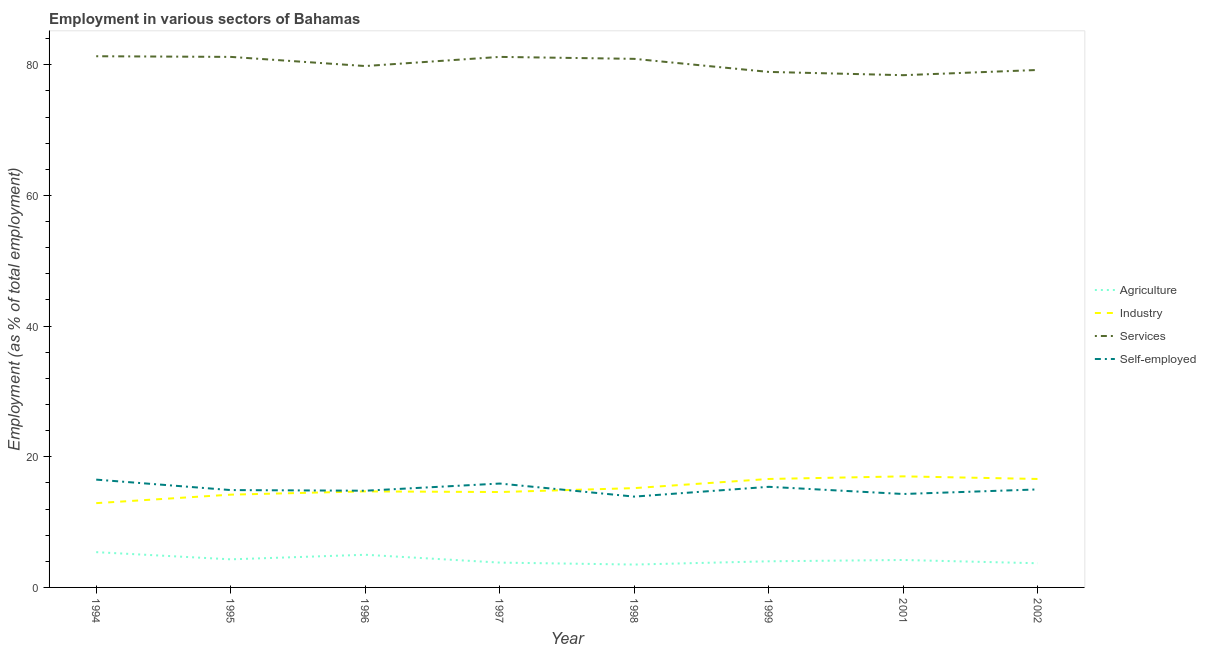How many different coloured lines are there?
Give a very brief answer. 4. What is the percentage of workers in agriculture in 1998?
Offer a very short reply. 3.5. Across all years, what is the maximum percentage of workers in services?
Your response must be concise. 81.3. In which year was the percentage of workers in industry maximum?
Offer a very short reply. 2001. What is the total percentage of workers in industry in the graph?
Your answer should be very brief. 121.8. What is the difference between the percentage of workers in industry in 1996 and that in 1998?
Keep it short and to the point. -0.5. What is the difference between the percentage of self employed workers in 2002 and the percentage of workers in agriculture in 2001?
Give a very brief answer. 10.8. What is the average percentage of workers in services per year?
Provide a short and direct response. 80.11. In the year 1995, what is the difference between the percentage of workers in industry and percentage of workers in services?
Give a very brief answer. -67. What is the ratio of the percentage of workers in services in 1995 to that in 1999?
Give a very brief answer. 1.03. Is the difference between the percentage of workers in agriculture in 1997 and 2001 greater than the difference between the percentage of workers in industry in 1997 and 2001?
Ensure brevity in your answer.  Yes. What is the difference between the highest and the second highest percentage of workers in agriculture?
Give a very brief answer. 0.4. What is the difference between the highest and the lowest percentage of self employed workers?
Your answer should be compact. 2.6. In how many years, is the percentage of workers in services greater than the average percentage of workers in services taken over all years?
Your answer should be compact. 4. Is the sum of the percentage of self employed workers in 1995 and 1997 greater than the maximum percentage of workers in agriculture across all years?
Keep it short and to the point. Yes. Does the percentage of workers in agriculture monotonically increase over the years?
Make the answer very short. No. How many lines are there?
Your answer should be very brief. 4. How many legend labels are there?
Your answer should be very brief. 4. What is the title of the graph?
Give a very brief answer. Employment in various sectors of Bahamas. What is the label or title of the Y-axis?
Your response must be concise. Employment (as % of total employment). What is the Employment (as % of total employment) in Agriculture in 1994?
Give a very brief answer. 5.4. What is the Employment (as % of total employment) of Industry in 1994?
Your answer should be very brief. 12.9. What is the Employment (as % of total employment) of Services in 1994?
Your answer should be compact. 81.3. What is the Employment (as % of total employment) of Agriculture in 1995?
Give a very brief answer. 4.3. What is the Employment (as % of total employment) in Industry in 1995?
Make the answer very short. 14.2. What is the Employment (as % of total employment) in Services in 1995?
Keep it short and to the point. 81.2. What is the Employment (as % of total employment) of Self-employed in 1995?
Provide a succinct answer. 14.9. What is the Employment (as % of total employment) of Agriculture in 1996?
Ensure brevity in your answer.  5. What is the Employment (as % of total employment) of Industry in 1996?
Your answer should be very brief. 14.7. What is the Employment (as % of total employment) in Services in 1996?
Ensure brevity in your answer.  79.8. What is the Employment (as % of total employment) in Self-employed in 1996?
Your answer should be very brief. 14.8. What is the Employment (as % of total employment) in Agriculture in 1997?
Ensure brevity in your answer.  3.8. What is the Employment (as % of total employment) of Industry in 1997?
Provide a short and direct response. 14.6. What is the Employment (as % of total employment) of Services in 1997?
Offer a terse response. 81.2. What is the Employment (as % of total employment) of Self-employed in 1997?
Provide a short and direct response. 15.9. What is the Employment (as % of total employment) in Agriculture in 1998?
Your answer should be compact. 3.5. What is the Employment (as % of total employment) of Industry in 1998?
Provide a succinct answer. 15.2. What is the Employment (as % of total employment) of Services in 1998?
Your answer should be compact. 80.9. What is the Employment (as % of total employment) of Self-employed in 1998?
Keep it short and to the point. 13.9. What is the Employment (as % of total employment) of Industry in 1999?
Make the answer very short. 16.6. What is the Employment (as % of total employment) of Services in 1999?
Offer a terse response. 78.9. What is the Employment (as % of total employment) in Self-employed in 1999?
Provide a short and direct response. 15.4. What is the Employment (as % of total employment) in Agriculture in 2001?
Offer a very short reply. 4.2. What is the Employment (as % of total employment) of Services in 2001?
Provide a succinct answer. 78.4. What is the Employment (as % of total employment) of Self-employed in 2001?
Make the answer very short. 14.3. What is the Employment (as % of total employment) in Agriculture in 2002?
Your response must be concise. 3.7. What is the Employment (as % of total employment) in Industry in 2002?
Ensure brevity in your answer.  16.6. What is the Employment (as % of total employment) in Services in 2002?
Your answer should be very brief. 79.2. What is the Employment (as % of total employment) of Self-employed in 2002?
Provide a succinct answer. 15. Across all years, what is the maximum Employment (as % of total employment) of Agriculture?
Offer a very short reply. 5.4. Across all years, what is the maximum Employment (as % of total employment) in Industry?
Make the answer very short. 17. Across all years, what is the maximum Employment (as % of total employment) of Services?
Provide a short and direct response. 81.3. Across all years, what is the maximum Employment (as % of total employment) of Self-employed?
Give a very brief answer. 16.5. Across all years, what is the minimum Employment (as % of total employment) of Industry?
Provide a short and direct response. 12.9. Across all years, what is the minimum Employment (as % of total employment) of Services?
Ensure brevity in your answer.  78.4. Across all years, what is the minimum Employment (as % of total employment) of Self-employed?
Keep it short and to the point. 13.9. What is the total Employment (as % of total employment) in Agriculture in the graph?
Ensure brevity in your answer.  33.9. What is the total Employment (as % of total employment) of Industry in the graph?
Keep it short and to the point. 121.8. What is the total Employment (as % of total employment) of Services in the graph?
Give a very brief answer. 640.9. What is the total Employment (as % of total employment) of Self-employed in the graph?
Make the answer very short. 120.7. What is the difference between the Employment (as % of total employment) of Self-employed in 1994 and that in 1995?
Provide a short and direct response. 1.6. What is the difference between the Employment (as % of total employment) in Agriculture in 1994 and that in 1996?
Ensure brevity in your answer.  0.4. What is the difference between the Employment (as % of total employment) of Services in 1994 and that in 1996?
Make the answer very short. 1.5. What is the difference between the Employment (as % of total employment) in Self-employed in 1994 and that in 1996?
Your response must be concise. 1.7. What is the difference between the Employment (as % of total employment) in Agriculture in 1994 and that in 1997?
Your response must be concise. 1.6. What is the difference between the Employment (as % of total employment) in Industry in 1994 and that in 1997?
Provide a succinct answer. -1.7. What is the difference between the Employment (as % of total employment) of Services in 1994 and that in 1997?
Give a very brief answer. 0.1. What is the difference between the Employment (as % of total employment) in Agriculture in 1994 and that in 1998?
Provide a succinct answer. 1.9. What is the difference between the Employment (as % of total employment) in Industry in 1994 and that in 1998?
Give a very brief answer. -2.3. What is the difference between the Employment (as % of total employment) of Services in 1994 and that in 1998?
Your answer should be compact. 0.4. What is the difference between the Employment (as % of total employment) in Self-employed in 1994 and that in 1998?
Your answer should be compact. 2.6. What is the difference between the Employment (as % of total employment) in Agriculture in 1994 and that in 1999?
Your answer should be very brief. 1.4. What is the difference between the Employment (as % of total employment) in Industry in 1994 and that in 1999?
Offer a very short reply. -3.7. What is the difference between the Employment (as % of total employment) of Services in 1994 and that in 1999?
Ensure brevity in your answer.  2.4. What is the difference between the Employment (as % of total employment) in Self-employed in 1994 and that in 1999?
Provide a short and direct response. 1.1. What is the difference between the Employment (as % of total employment) in Agriculture in 1994 and that in 2001?
Give a very brief answer. 1.2. What is the difference between the Employment (as % of total employment) in Industry in 1994 and that in 2001?
Provide a short and direct response. -4.1. What is the difference between the Employment (as % of total employment) of Services in 1994 and that in 2001?
Give a very brief answer. 2.9. What is the difference between the Employment (as % of total employment) of Self-employed in 1994 and that in 2001?
Provide a succinct answer. 2.2. What is the difference between the Employment (as % of total employment) of Agriculture in 1994 and that in 2002?
Keep it short and to the point. 1.7. What is the difference between the Employment (as % of total employment) in Services in 1994 and that in 2002?
Give a very brief answer. 2.1. What is the difference between the Employment (as % of total employment) in Agriculture in 1995 and that in 1996?
Your answer should be very brief. -0.7. What is the difference between the Employment (as % of total employment) of Services in 1995 and that in 1996?
Provide a succinct answer. 1.4. What is the difference between the Employment (as % of total employment) in Self-employed in 1995 and that in 1996?
Keep it short and to the point. 0.1. What is the difference between the Employment (as % of total employment) in Self-employed in 1995 and that in 1997?
Provide a short and direct response. -1. What is the difference between the Employment (as % of total employment) of Agriculture in 1995 and that in 1998?
Provide a succinct answer. 0.8. What is the difference between the Employment (as % of total employment) in Services in 1995 and that in 1998?
Your answer should be compact. 0.3. What is the difference between the Employment (as % of total employment) in Agriculture in 1995 and that in 1999?
Make the answer very short. 0.3. What is the difference between the Employment (as % of total employment) of Industry in 1995 and that in 1999?
Your response must be concise. -2.4. What is the difference between the Employment (as % of total employment) of Industry in 1995 and that in 2001?
Ensure brevity in your answer.  -2.8. What is the difference between the Employment (as % of total employment) in Services in 1995 and that in 2001?
Offer a terse response. 2.8. What is the difference between the Employment (as % of total employment) in Self-employed in 1995 and that in 2001?
Make the answer very short. 0.6. What is the difference between the Employment (as % of total employment) of Agriculture in 1995 and that in 2002?
Ensure brevity in your answer.  0.6. What is the difference between the Employment (as % of total employment) in Industry in 1995 and that in 2002?
Give a very brief answer. -2.4. What is the difference between the Employment (as % of total employment) of Agriculture in 1996 and that in 1997?
Your answer should be compact. 1.2. What is the difference between the Employment (as % of total employment) of Industry in 1996 and that in 1997?
Provide a succinct answer. 0.1. What is the difference between the Employment (as % of total employment) of Services in 1996 and that in 1997?
Your response must be concise. -1.4. What is the difference between the Employment (as % of total employment) of Self-employed in 1996 and that in 1997?
Offer a terse response. -1.1. What is the difference between the Employment (as % of total employment) of Industry in 1996 and that in 1998?
Make the answer very short. -0.5. What is the difference between the Employment (as % of total employment) in Self-employed in 1996 and that in 1998?
Provide a succinct answer. 0.9. What is the difference between the Employment (as % of total employment) in Self-employed in 1996 and that in 1999?
Keep it short and to the point. -0.6. What is the difference between the Employment (as % of total employment) in Agriculture in 1996 and that in 2001?
Your answer should be compact. 0.8. What is the difference between the Employment (as % of total employment) in Industry in 1996 and that in 2001?
Give a very brief answer. -2.3. What is the difference between the Employment (as % of total employment) in Services in 1996 and that in 2001?
Keep it short and to the point. 1.4. What is the difference between the Employment (as % of total employment) of Agriculture in 1996 and that in 2002?
Offer a very short reply. 1.3. What is the difference between the Employment (as % of total employment) in Services in 1996 and that in 2002?
Ensure brevity in your answer.  0.6. What is the difference between the Employment (as % of total employment) of Agriculture in 1997 and that in 1998?
Offer a terse response. 0.3. What is the difference between the Employment (as % of total employment) of Industry in 1997 and that in 1998?
Make the answer very short. -0.6. What is the difference between the Employment (as % of total employment) in Services in 1997 and that in 1998?
Offer a very short reply. 0.3. What is the difference between the Employment (as % of total employment) in Self-employed in 1997 and that in 1998?
Your response must be concise. 2. What is the difference between the Employment (as % of total employment) of Industry in 1997 and that in 1999?
Offer a terse response. -2. What is the difference between the Employment (as % of total employment) in Agriculture in 1997 and that in 2001?
Provide a succinct answer. -0.4. What is the difference between the Employment (as % of total employment) in Industry in 1997 and that in 2001?
Your answer should be very brief. -2.4. What is the difference between the Employment (as % of total employment) in Self-employed in 1997 and that in 2001?
Keep it short and to the point. 1.6. What is the difference between the Employment (as % of total employment) in Agriculture in 1997 and that in 2002?
Ensure brevity in your answer.  0.1. What is the difference between the Employment (as % of total employment) in Self-employed in 1997 and that in 2002?
Your answer should be very brief. 0.9. What is the difference between the Employment (as % of total employment) of Agriculture in 1998 and that in 1999?
Provide a short and direct response. -0.5. What is the difference between the Employment (as % of total employment) in Industry in 1998 and that in 1999?
Your answer should be compact. -1.4. What is the difference between the Employment (as % of total employment) of Services in 1998 and that in 1999?
Offer a terse response. 2. What is the difference between the Employment (as % of total employment) of Agriculture in 1998 and that in 2001?
Make the answer very short. -0.7. What is the difference between the Employment (as % of total employment) in Industry in 1998 and that in 2001?
Ensure brevity in your answer.  -1.8. What is the difference between the Employment (as % of total employment) of Services in 1998 and that in 2001?
Keep it short and to the point. 2.5. What is the difference between the Employment (as % of total employment) of Self-employed in 1998 and that in 2002?
Your response must be concise. -1.1. What is the difference between the Employment (as % of total employment) in Agriculture in 1999 and that in 2001?
Keep it short and to the point. -0.2. What is the difference between the Employment (as % of total employment) of Services in 1999 and that in 2001?
Provide a succinct answer. 0.5. What is the difference between the Employment (as % of total employment) of Self-employed in 1999 and that in 2001?
Offer a very short reply. 1.1. What is the difference between the Employment (as % of total employment) of Agriculture in 1999 and that in 2002?
Your response must be concise. 0.3. What is the difference between the Employment (as % of total employment) of Self-employed in 1999 and that in 2002?
Your answer should be very brief. 0.4. What is the difference between the Employment (as % of total employment) in Industry in 2001 and that in 2002?
Offer a very short reply. 0.4. What is the difference between the Employment (as % of total employment) of Self-employed in 2001 and that in 2002?
Provide a succinct answer. -0.7. What is the difference between the Employment (as % of total employment) in Agriculture in 1994 and the Employment (as % of total employment) in Industry in 1995?
Offer a very short reply. -8.8. What is the difference between the Employment (as % of total employment) of Agriculture in 1994 and the Employment (as % of total employment) of Services in 1995?
Make the answer very short. -75.8. What is the difference between the Employment (as % of total employment) of Industry in 1994 and the Employment (as % of total employment) of Services in 1995?
Provide a succinct answer. -68.3. What is the difference between the Employment (as % of total employment) in Services in 1994 and the Employment (as % of total employment) in Self-employed in 1995?
Make the answer very short. 66.4. What is the difference between the Employment (as % of total employment) of Agriculture in 1994 and the Employment (as % of total employment) of Services in 1996?
Offer a terse response. -74.4. What is the difference between the Employment (as % of total employment) in Agriculture in 1994 and the Employment (as % of total employment) in Self-employed in 1996?
Make the answer very short. -9.4. What is the difference between the Employment (as % of total employment) of Industry in 1994 and the Employment (as % of total employment) of Services in 1996?
Your answer should be very brief. -66.9. What is the difference between the Employment (as % of total employment) of Services in 1994 and the Employment (as % of total employment) of Self-employed in 1996?
Provide a succinct answer. 66.5. What is the difference between the Employment (as % of total employment) of Agriculture in 1994 and the Employment (as % of total employment) of Services in 1997?
Give a very brief answer. -75.8. What is the difference between the Employment (as % of total employment) of Industry in 1994 and the Employment (as % of total employment) of Services in 1997?
Keep it short and to the point. -68.3. What is the difference between the Employment (as % of total employment) in Industry in 1994 and the Employment (as % of total employment) in Self-employed in 1997?
Your answer should be very brief. -3. What is the difference between the Employment (as % of total employment) in Services in 1994 and the Employment (as % of total employment) in Self-employed in 1997?
Provide a short and direct response. 65.4. What is the difference between the Employment (as % of total employment) in Agriculture in 1994 and the Employment (as % of total employment) in Industry in 1998?
Your response must be concise. -9.8. What is the difference between the Employment (as % of total employment) of Agriculture in 1994 and the Employment (as % of total employment) of Services in 1998?
Offer a very short reply. -75.5. What is the difference between the Employment (as % of total employment) in Agriculture in 1994 and the Employment (as % of total employment) in Self-employed in 1998?
Provide a succinct answer. -8.5. What is the difference between the Employment (as % of total employment) of Industry in 1994 and the Employment (as % of total employment) of Services in 1998?
Keep it short and to the point. -68. What is the difference between the Employment (as % of total employment) of Industry in 1994 and the Employment (as % of total employment) of Self-employed in 1998?
Provide a succinct answer. -1. What is the difference between the Employment (as % of total employment) of Services in 1994 and the Employment (as % of total employment) of Self-employed in 1998?
Offer a terse response. 67.4. What is the difference between the Employment (as % of total employment) in Agriculture in 1994 and the Employment (as % of total employment) in Industry in 1999?
Keep it short and to the point. -11.2. What is the difference between the Employment (as % of total employment) in Agriculture in 1994 and the Employment (as % of total employment) in Services in 1999?
Offer a very short reply. -73.5. What is the difference between the Employment (as % of total employment) of Agriculture in 1994 and the Employment (as % of total employment) of Self-employed in 1999?
Keep it short and to the point. -10. What is the difference between the Employment (as % of total employment) in Industry in 1994 and the Employment (as % of total employment) in Services in 1999?
Your answer should be very brief. -66. What is the difference between the Employment (as % of total employment) in Industry in 1994 and the Employment (as % of total employment) in Self-employed in 1999?
Keep it short and to the point. -2.5. What is the difference between the Employment (as % of total employment) in Services in 1994 and the Employment (as % of total employment) in Self-employed in 1999?
Your response must be concise. 65.9. What is the difference between the Employment (as % of total employment) in Agriculture in 1994 and the Employment (as % of total employment) in Industry in 2001?
Provide a succinct answer. -11.6. What is the difference between the Employment (as % of total employment) in Agriculture in 1994 and the Employment (as % of total employment) in Services in 2001?
Your answer should be compact. -73. What is the difference between the Employment (as % of total employment) in Agriculture in 1994 and the Employment (as % of total employment) in Self-employed in 2001?
Give a very brief answer. -8.9. What is the difference between the Employment (as % of total employment) in Industry in 1994 and the Employment (as % of total employment) in Services in 2001?
Your answer should be very brief. -65.5. What is the difference between the Employment (as % of total employment) of Industry in 1994 and the Employment (as % of total employment) of Self-employed in 2001?
Your response must be concise. -1.4. What is the difference between the Employment (as % of total employment) in Services in 1994 and the Employment (as % of total employment) in Self-employed in 2001?
Your answer should be compact. 67. What is the difference between the Employment (as % of total employment) in Agriculture in 1994 and the Employment (as % of total employment) in Industry in 2002?
Your answer should be compact. -11.2. What is the difference between the Employment (as % of total employment) in Agriculture in 1994 and the Employment (as % of total employment) in Services in 2002?
Your answer should be compact. -73.8. What is the difference between the Employment (as % of total employment) of Industry in 1994 and the Employment (as % of total employment) of Services in 2002?
Offer a very short reply. -66.3. What is the difference between the Employment (as % of total employment) of Industry in 1994 and the Employment (as % of total employment) of Self-employed in 2002?
Your answer should be very brief. -2.1. What is the difference between the Employment (as % of total employment) in Services in 1994 and the Employment (as % of total employment) in Self-employed in 2002?
Make the answer very short. 66.3. What is the difference between the Employment (as % of total employment) of Agriculture in 1995 and the Employment (as % of total employment) of Industry in 1996?
Offer a terse response. -10.4. What is the difference between the Employment (as % of total employment) in Agriculture in 1995 and the Employment (as % of total employment) in Services in 1996?
Ensure brevity in your answer.  -75.5. What is the difference between the Employment (as % of total employment) in Industry in 1995 and the Employment (as % of total employment) in Services in 1996?
Give a very brief answer. -65.6. What is the difference between the Employment (as % of total employment) in Industry in 1995 and the Employment (as % of total employment) in Self-employed in 1996?
Your answer should be very brief. -0.6. What is the difference between the Employment (as % of total employment) of Services in 1995 and the Employment (as % of total employment) of Self-employed in 1996?
Ensure brevity in your answer.  66.4. What is the difference between the Employment (as % of total employment) of Agriculture in 1995 and the Employment (as % of total employment) of Industry in 1997?
Your answer should be very brief. -10.3. What is the difference between the Employment (as % of total employment) of Agriculture in 1995 and the Employment (as % of total employment) of Services in 1997?
Keep it short and to the point. -76.9. What is the difference between the Employment (as % of total employment) in Industry in 1995 and the Employment (as % of total employment) in Services in 1997?
Give a very brief answer. -67. What is the difference between the Employment (as % of total employment) of Services in 1995 and the Employment (as % of total employment) of Self-employed in 1997?
Your response must be concise. 65.3. What is the difference between the Employment (as % of total employment) of Agriculture in 1995 and the Employment (as % of total employment) of Industry in 1998?
Your answer should be compact. -10.9. What is the difference between the Employment (as % of total employment) in Agriculture in 1995 and the Employment (as % of total employment) in Services in 1998?
Your response must be concise. -76.6. What is the difference between the Employment (as % of total employment) in Agriculture in 1995 and the Employment (as % of total employment) in Self-employed in 1998?
Make the answer very short. -9.6. What is the difference between the Employment (as % of total employment) of Industry in 1995 and the Employment (as % of total employment) of Services in 1998?
Your answer should be very brief. -66.7. What is the difference between the Employment (as % of total employment) in Industry in 1995 and the Employment (as % of total employment) in Self-employed in 1998?
Keep it short and to the point. 0.3. What is the difference between the Employment (as % of total employment) in Services in 1995 and the Employment (as % of total employment) in Self-employed in 1998?
Offer a terse response. 67.3. What is the difference between the Employment (as % of total employment) in Agriculture in 1995 and the Employment (as % of total employment) in Services in 1999?
Ensure brevity in your answer.  -74.6. What is the difference between the Employment (as % of total employment) of Agriculture in 1995 and the Employment (as % of total employment) of Self-employed in 1999?
Keep it short and to the point. -11.1. What is the difference between the Employment (as % of total employment) of Industry in 1995 and the Employment (as % of total employment) of Services in 1999?
Your answer should be very brief. -64.7. What is the difference between the Employment (as % of total employment) in Industry in 1995 and the Employment (as % of total employment) in Self-employed in 1999?
Offer a terse response. -1.2. What is the difference between the Employment (as % of total employment) of Services in 1995 and the Employment (as % of total employment) of Self-employed in 1999?
Keep it short and to the point. 65.8. What is the difference between the Employment (as % of total employment) in Agriculture in 1995 and the Employment (as % of total employment) in Industry in 2001?
Your answer should be very brief. -12.7. What is the difference between the Employment (as % of total employment) in Agriculture in 1995 and the Employment (as % of total employment) in Services in 2001?
Provide a short and direct response. -74.1. What is the difference between the Employment (as % of total employment) of Agriculture in 1995 and the Employment (as % of total employment) of Self-employed in 2001?
Offer a terse response. -10. What is the difference between the Employment (as % of total employment) of Industry in 1995 and the Employment (as % of total employment) of Services in 2001?
Offer a terse response. -64.2. What is the difference between the Employment (as % of total employment) of Industry in 1995 and the Employment (as % of total employment) of Self-employed in 2001?
Your response must be concise. -0.1. What is the difference between the Employment (as % of total employment) of Services in 1995 and the Employment (as % of total employment) of Self-employed in 2001?
Offer a terse response. 66.9. What is the difference between the Employment (as % of total employment) of Agriculture in 1995 and the Employment (as % of total employment) of Services in 2002?
Provide a succinct answer. -74.9. What is the difference between the Employment (as % of total employment) of Agriculture in 1995 and the Employment (as % of total employment) of Self-employed in 2002?
Give a very brief answer. -10.7. What is the difference between the Employment (as % of total employment) in Industry in 1995 and the Employment (as % of total employment) in Services in 2002?
Give a very brief answer. -65. What is the difference between the Employment (as % of total employment) in Industry in 1995 and the Employment (as % of total employment) in Self-employed in 2002?
Give a very brief answer. -0.8. What is the difference between the Employment (as % of total employment) of Services in 1995 and the Employment (as % of total employment) of Self-employed in 2002?
Your response must be concise. 66.2. What is the difference between the Employment (as % of total employment) of Agriculture in 1996 and the Employment (as % of total employment) of Services in 1997?
Your answer should be compact. -76.2. What is the difference between the Employment (as % of total employment) in Agriculture in 1996 and the Employment (as % of total employment) in Self-employed in 1997?
Your response must be concise. -10.9. What is the difference between the Employment (as % of total employment) in Industry in 1996 and the Employment (as % of total employment) in Services in 1997?
Your answer should be compact. -66.5. What is the difference between the Employment (as % of total employment) of Industry in 1996 and the Employment (as % of total employment) of Self-employed in 1997?
Offer a very short reply. -1.2. What is the difference between the Employment (as % of total employment) of Services in 1996 and the Employment (as % of total employment) of Self-employed in 1997?
Keep it short and to the point. 63.9. What is the difference between the Employment (as % of total employment) of Agriculture in 1996 and the Employment (as % of total employment) of Industry in 1998?
Provide a short and direct response. -10.2. What is the difference between the Employment (as % of total employment) of Agriculture in 1996 and the Employment (as % of total employment) of Services in 1998?
Ensure brevity in your answer.  -75.9. What is the difference between the Employment (as % of total employment) in Agriculture in 1996 and the Employment (as % of total employment) in Self-employed in 1998?
Your answer should be compact. -8.9. What is the difference between the Employment (as % of total employment) of Industry in 1996 and the Employment (as % of total employment) of Services in 1998?
Offer a terse response. -66.2. What is the difference between the Employment (as % of total employment) of Industry in 1996 and the Employment (as % of total employment) of Self-employed in 1998?
Your response must be concise. 0.8. What is the difference between the Employment (as % of total employment) of Services in 1996 and the Employment (as % of total employment) of Self-employed in 1998?
Give a very brief answer. 65.9. What is the difference between the Employment (as % of total employment) of Agriculture in 1996 and the Employment (as % of total employment) of Industry in 1999?
Your response must be concise. -11.6. What is the difference between the Employment (as % of total employment) of Agriculture in 1996 and the Employment (as % of total employment) of Services in 1999?
Ensure brevity in your answer.  -73.9. What is the difference between the Employment (as % of total employment) of Agriculture in 1996 and the Employment (as % of total employment) of Self-employed in 1999?
Your response must be concise. -10.4. What is the difference between the Employment (as % of total employment) of Industry in 1996 and the Employment (as % of total employment) of Services in 1999?
Offer a very short reply. -64.2. What is the difference between the Employment (as % of total employment) in Industry in 1996 and the Employment (as % of total employment) in Self-employed in 1999?
Keep it short and to the point. -0.7. What is the difference between the Employment (as % of total employment) of Services in 1996 and the Employment (as % of total employment) of Self-employed in 1999?
Offer a terse response. 64.4. What is the difference between the Employment (as % of total employment) of Agriculture in 1996 and the Employment (as % of total employment) of Industry in 2001?
Your response must be concise. -12. What is the difference between the Employment (as % of total employment) in Agriculture in 1996 and the Employment (as % of total employment) in Services in 2001?
Provide a succinct answer. -73.4. What is the difference between the Employment (as % of total employment) of Industry in 1996 and the Employment (as % of total employment) of Services in 2001?
Your answer should be very brief. -63.7. What is the difference between the Employment (as % of total employment) of Industry in 1996 and the Employment (as % of total employment) of Self-employed in 2001?
Provide a succinct answer. 0.4. What is the difference between the Employment (as % of total employment) of Services in 1996 and the Employment (as % of total employment) of Self-employed in 2001?
Offer a very short reply. 65.5. What is the difference between the Employment (as % of total employment) of Agriculture in 1996 and the Employment (as % of total employment) of Industry in 2002?
Ensure brevity in your answer.  -11.6. What is the difference between the Employment (as % of total employment) of Agriculture in 1996 and the Employment (as % of total employment) of Services in 2002?
Your response must be concise. -74.2. What is the difference between the Employment (as % of total employment) in Industry in 1996 and the Employment (as % of total employment) in Services in 2002?
Provide a succinct answer. -64.5. What is the difference between the Employment (as % of total employment) of Industry in 1996 and the Employment (as % of total employment) of Self-employed in 2002?
Your response must be concise. -0.3. What is the difference between the Employment (as % of total employment) of Services in 1996 and the Employment (as % of total employment) of Self-employed in 2002?
Give a very brief answer. 64.8. What is the difference between the Employment (as % of total employment) of Agriculture in 1997 and the Employment (as % of total employment) of Services in 1998?
Offer a terse response. -77.1. What is the difference between the Employment (as % of total employment) of Industry in 1997 and the Employment (as % of total employment) of Services in 1998?
Make the answer very short. -66.3. What is the difference between the Employment (as % of total employment) of Industry in 1997 and the Employment (as % of total employment) of Self-employed in 1998?
Keep it short and to the point. 0.7. What is the difference between the Employment (as % of total employment) of Services in 1997 and the Employment (as % of total employment) of Self-employed in 1998?
Your answer should be compact. 67.3. What is the difference between the Employment (as % of total employment) in Agriculture in 1997 and the Employment (as % of total employment) in Services in 1999?
Make the answer very short. -75.1. What is the difference between the Employment (as % of total employment) in Agriculture in 1997 and the Employment (as % of total employment) in Self-employed in 1999?
Your answer should be compact. -11.6. What is the difference between the Employment (as % of total employment) in Industry in 1997 and the Employment (as % of total employment) in Services in 1999?
Provide a short and direct response. -64.3. What is the difference between the Employment (as % of total employment) of Industry in 1997 and the Employment (as % of total employment) of Self-employed in 1999?
Ensure brevity in your answer.  -0.8. What is the difference between the Employment (as % of total employment) of Services in 1997 and the Employment (as % of total employment) of Self-employed in 1999?
Ensure brevity in your answer.  65.8. What is the difference between the Employment (as % of total employment) in Agriculture in 1997 and the Employment (as % of total employment) in Industry in 2001?
Offer a terse response. -13.2. What is the difference between the Employment (as % of total employment) in Agriculture in 1997 and the Employment (as % of total employment) in Services in 2001?
Offer a very short reply. -74.6. What is the difference between the Employment (as % of total employment) in Agriculture in 1997 and the Employment (as % of total employment) in Self-employed in 2001?
Provide a short and direct response. -10.5. What is the difference between the Employment (as % of total employment) of Industry in 1997 and the Employment (as % of total employment) of Services in 2001?
Provide a short and direct response. -63.8. What is the difference between the Employment (as % of total employment) of Industry in 1997 and the Employment (as % of total employment) of Self-employed in 2001?
Your answer should be compact. 0.3. What is the difference between the Employment (as % of total employment) of Services in 1997 and the Employment (as % of total employment) of Self-employed in 2001?
Ensure brevity in your answer.  66.9. What is the difference between the Employment (as % of total employment) in Agriculture in 1997 and the Employment (as % of total employment) in Industry in 2002?
Your answer should be very brief. -12.8. What is the difference between the Employment (as % of total employment) of Agriculture in 1997 and the Employment (as % of total employment) of Services in 2002?
Offer a terse response. -75.4. What is the difference between the Employment (as % of total employment) in Agriculture in 1997 and the Employment (as % of total employment) in Self-employed in 2002?
Provide a succinct answer. -11.2. What is the difference between the Employment (as % of total employment) in Industry in 1997 and the Employment (as % of total employment) in Services in 2002?
Your answer should be compact. -64.6. What is the difference between the Employment (as % of total employment) of Services in 1997 and the Employment (as % of total employment) of Self-employed in 2002?
Provide a succinct answer. 66.2. What is the difference between the Employment (as % of total employment) in Agriculture in 1998 and the Employment (as % of total employment) in Industry in 1999?
Your answer should be very brief. -13.1. What is the difference between the Employment (as % of total employment) in Agriculture in 1998 and the Employment (as % of total employment) in Services in 1999?
Offer a very short reply. -75.4. What is the difference between the Employment (as % of total employment) of Agriculture in 1998 and the Employment (as % of total employment) of Self-employed in 1999?
Provide a short and direct response. -11.9. What is the difference between the Employment (as % of total employment) in Industry in 1998 and the Employment (as % of total employment) in Services in 1999?
Your response must be concise. -63.7. What is the difference between the Employment (as % of total employment) of Services in 1998 and the Employment (as % of total employment) of Self-employed in 1999?
Provide a succinct answer. 65.5. What is the difference between the Employment (as % of total employment) of Agriculture in 1998 and the Employment (as % of total employment) of Services in 2001?
Your answer should be compact. -74.9. What is the difference between the Employment (as % of total employment) in Industry in 1998 and the Employment (as % of total employment) in Services in 2001?
Offer a very short reply. -63.2. What is the difference between the Employment (as % of total employment) in Services in 1998 and the Employment (as % of total employment) in Self-employed in 2001?
Provide a short and direct response. 66.6. What is the difference between the Employment (as % of total employment) in Agriculture in 1998 and the Employment (as % of total employment) in Services in 2002?
Provide a short and direct response. -75.7. What is the difference between the Employment (as % of total employment) of Industry in 1998 and the Employment (as % of total employment) of Services in 2002?
Give a very brief answer. -64. What is the difference between the Employment (as % of total employment) in Industry in 1998 and the Employment (as % of total employment) in Self-employed in 2002?
Offer a terse response. 0.2. What is the difference between the Employment (as % of total employment) in Services in 1998 and the Employment (as % of total employment) in Self-employed in 2002?
Give a very brief answer. 65.9. What is the difference between the Employment (as % of total employment) of Agriculture in 1999 and the Employment (as % of total employment) of Services in 2001?
Ensure brevity in your answer.  -74.4. What is the difference between the Employment (as % of total employment) in Agriculture in 1999 and the Employment (as % of total employment) in Self-employed in 2001?
Offer a terse response. -10.3. What is the difference between the Employment (as % of total employment) of Industry in 1999 and the Employment (as % of total employment) of Services in 2001?
Keep it short and to the point. -61.8. What is the difference between the Employment (as % of total employment) of Services in 1999 and the Employment (as % of total employment) of Self-employed in 2001?
Give a very brief answer. 64.6. What is the difference between the Employment (as % of total employment) in Agriculture in 1999 and the Employment (as % of total employment) in Industry in 2002?
Make the answer very short. -12.6. What is the difference between the Employment (as % of total employment) in Agriculture in 1999 and the Employment (as % of total employment) in Services in 2002?
Offer a terse response. -75.2. What is the difference between the Employment (as % of total employment) of Agriculture in 1999 and the Employment (as % of total employment) of Self-employed in 2002?
Keep it short and to the point. -11. What is the difference between the Employment (as % of total employment) in Industry in 1999 and the Employment (as % of total employment) in Services in 2002?
Keep it short and to the point. -62.6. What is the difference between the Employment (as % of total employment) in Services in 1999 and the Employment (as % of total employment) in Self-employed in 2002?
Make the answer very short. 63.9. What is the difference between the Employment (as % of total employment) of Agriculture in 2001 and the Employment (as % of total employment) of Services in 2002?
Ensure brevity in your answer.  -75. What is the difference between the Employment (as % of total employment) in Industry in 2001 and the Employment (as % of total employment) in Services in 2002?
Give a very brief answer. -62.2. What is the difference between the Employment (as % of total employment) in Industry in 2001 and the Employment (as % of total employment) in Self-employed in 2002?
Offer a terse response. 2. What is the difference between the Employment (as % of total employment) in Services in 2001 and the Employment (as % of total employment) in Self-employed in 2002?
Give a very brief answer. 63.4. What is the average Employment (as % of total employment) of Agriculture per year?
Make the answer very short. 4.24. What is the average Employment (as % of total employment) of Industry per year?
Your answer should be compact. 15.22. What is the average Employment (as % of total employment) of Services per year?
Offer a very short reply. 80.11. What is the average Employment (as % of total employment) in Self-employed per year?
Keep it short and to the point. 15.09. In the year 1994, what is the difference between the Employment (as % of total employment) of Agriculture and Employment (as % of total employment) of Industry?
Provide a succinct answer. -7.5. In the year 1994, what is the difference between the Employment (as % of total employment) of Agriculture and Employment (as % of total employment) of Services?
Your response must be concise. -75.9. In the year 1994, what is the difference between the Employment (as % of total employment) in Agriculture and Employment (as % of total employment) in Self-employed?
Give a very brief answer. -11.1. In the year 1994, what is the difference between the Employment (as % of total employment) in Industry and Employment (as % of total employment) in Services?
Offer a very short reply. -68.4. In the year 1994, what is the difference between the Employment (as % of total employment) of Services and Employment (as % of total employment) of Self-employed?
Your answer should be compact. 64.8. In the year 1995, what is the difference between the Employment (as % of total employment) of Agriculture and Employment (as % of total employment) of Industry?
Keep it short and to the point. -9.9. In the year 1995, what is the difference between the Employment (as % of total employment) in Agriculture and Employment (as % of total employment) in Services?
Your answer should be very brief. -76.9. In the year 1995, what is the difference between the Employment (as % of total employment) in Industry and Employment (as % of total employment) in Services?
Give a very brief answer. -67. In the year 1995, what is the difference between the Employment (as % of total employment) of Industry and Employment (as % of total employment) of Self-employed?
Offer a terse response. -0.7. In the year 1995, what is the difference between the Employment (as % of total employment) of Services and Employment (as % of total employment) of Self-employed?
Offer a terse response. 66.3. In the year 1996, what is the difference between the Employment (as % of total employment) of Agriculture and Employment (as % of total employment) of Services?
Your answer should be compact. -74.8. In the year 1996, what is the difference between the Employment (as % of total employment) of Industry and Employment (as % of total employment) of Services?
Ensure brevity in your answer.  -65.1. In the year 1996, what is the difference between the Employment (as % of total employment) of Industry and Employment (as % of total employment) of Self-employed?
Your answer should be very brief. -0.1. In the year 1997, what is the difference between the Employment (as % of total employment) of Agriculture and Employment (as % of total employment) of Industry?
Ensure brevity in your answer.  -10.8. In the year 1997, what is the difference between the Employment (as % of total employment) of Agriculture and Employment (as % of total employment) of Services?
Provide a short and direct response. -77.4. In the year 1997, what is the difference between the Employment (as % of total employment) in Industry and Employment (as % of total employment) in Services?
Provide a succinct answer. -66.6. In the year 1997, what is the difference between the Employment (as % of total employment) of Industry and Employment (as % of total employment) of Self-employed?
Make the answer very short. -1.3. In the year 1997, what is the difference between the Employment (as % of total employment) in Services and Employment (as % of total employment) in Self-employed?
Ensure brevity in your answer.  65.3. In the year 1998, what is the difference between the Employment (as % of total employment) of Agriculture and Employment (as % of total employment) of Services?
Keep it short and to the point. -77.4. In the year 1998, what is the difference between the Employment (as % of total employment) in Agriculture and Employment (as % of total employment) in Self-employed?
Offer a very short reply. -10.4. In the year 1998, what is the difference between the Employment (as % of total employment) of Industry and Employment (as % of total employment) of Services?
Ensure brevity in your answer.  -65.7. In the year 1998, what is the difference between the Employment (as % of total employment) of Industry and Employment (as % of total employment) of Self-employed?
Make the answer very short. 1.3. In the year 1999, what is the difference between the Employment (as % of total employment) of Agriculture and Employment (as % of total employment) of Industry?
Your response must be concise. -12.6. In the year 1999, what is the difference between the Employment (as % of total employment) of Agriculture and Employment (as % of total employment) of Services?
Offer a terse response. -74.9. In the year 1999, what is the difference between the Employment (as % of total employment) in Agriculture and Employment (as % of total employment) in Self-employed?
Your answer should be very brief. -11.4. In the year 1999, what is the difference between the Employment (as % of total employment) in Industry and Employment (as % of total employment) in Services?
Offer a very short reply. -62.3. In the year 1999, what is the difference between the Employment (as % of total employment) in Industry and Employment (as % of total employment) in Self-employed?
Your answer should be very brief. 1.2. In the year 1999, what is the difference between the Employment (as % of total employment) in Services and Employment (as % of total employment) in Self-employed?
Offer a terse response. 63.5. In the year 2001, what is the difference between the Employment (as % of total employment) of Agriculture and Employment (as % of total employment) of Services?
Your answer should be compact. -74.2. In the year 2001, what is the difference between the Employment (as % of total employment) in Industry and Employment (as % of total employment) in Services?
Give a very brief answer. -61.4. In the year 2001, what is the difference between the Employment (as % of total employment) of Industry and Employment (as % of total employment) of Self-employed?
Make the answer very short. 2.7. In the year 2001, what is the difference between the Employment (as % of total employment) in Services and Employment (as % of total employment) in Self-employed?
Offer a very short reply. 64.1. In the year 2002, what is the difference between the Employment (as % of total employment) of Agriculture and Employment (as % of total employment) of Services?
Keep it short and to the point. -75.5. In the year 2002, what is the difference between the Employment (as % of total employment) of Agriculture and Employment (as % of total employment) of Self-employed?
Keep it short and to the point. -11.3. In the year 2002, what is the difference between the Employment (as % of total employment) of Industry and Employment (as % of total employment) of Services?
Your answer should be very brief. -62.6. In the year 2002, what is the difference between the Employment (as % of total employment) of Industry and Employment (as % of total employment) of Self-employed?
Provide a short and direct response. 1.6. In the year 2002, what is the difference between the Employment (as % of total employment) in Services and Employment (as % of total employment) in Self-employed?
Provide a short and direct response. 64.2. What is the ratio of the Employment (as % of total employment) in Agriculture in 1994 to that in 1995?
Your answer should be very brief. 1.26. What is the ratio of the Employment (as % of total employment) in Industry in 1994 to that in 1995?
Your response must be concise. 0.91. What is the ratio of the Employment (as % of total employment) of Self-employed in 1994 to that in 1995?
Offer a terse response. 1.11. What is the ratio of the Employment (as % of total employment) in Industry in 1994 to that in 1996?
Your response must be concise. 0.88. What is the ratio of the Employment (as % of total employment) of Services in 1994 to that in 1996?
Make the answer very short. 1.02. What is the ratio of the Employment (as % of total employment) in Self-employed in 1994 to that in 1996?
Your answer should be compact. 1.11. What is the ratio of the Employment (as % of total employment) of Agriculture in 1994 to that in 1997?
Your answer should be very brief. 1.42. What is the ratio of the Employment (as % of total employment) of Industry in 1994 to that in 1997?
Give a very brief answer. 0.88. What is the ratio of the Employment (as % of total employment) in Self-employed in 1994 to that in 1997?
Your response must be concise. 1.04. What is the ratio of the Employment (as % of total employment) of Agriculture in 1994 to that in 1998?
Offer a terse response. 1.54. What is the ratio of the Employment (as % of total employment) in Industry in 1994 to that in 1998?
Make the answer very short. 0.85. What is the ratio of the Employment (as % of total employment) of Services in 1994 to that in 1998?
Your answer should be very brief. 1. What is the ratio of the Employment (as % of total employment) of Self-employed in 1994 to that in 1998?
Ensure brevity in your answer.  1.19. What is the ratio of the Employment (as % of total employment) of Agriculture in 1994 to that in 1999?
Make the answer very short. 1.35. What is the ratio of the Employment (as % of total employment) of Industry in 1994 to that in 1999?
Your answer should be compact. 0.78. What is the ratio of the Employment (as % of total employment) in Services in 1994 to that in 1999?
Provide a short and direct response. 1.03. What is the ratio of the Employment (as % of total employment) of Self-employed in 1994 to that in 1999?
Keep it short and to the point. 1.07. What is the ratio of the Employment (as % of total employment) in Industry in 1994 to that in 2001?
Ensure brevity in your answer.  0.76. What is the ratio of the Employment (as % of total employment) in Services in 1994 to that in 2001?
Your answer should be very brief. 1.04. What is the ratio of the Employment (as % of total employment) of Self-employed in 1994 to that in 2001?
Your answer should be compact. 1.15. What is the ratio of the Employment (as % of total employment) of Agriculture in 1994 to that in 2002?
Give a very brief answer. 1.46. What is the ratio of the Employment (as % of total employment) in Industry in 1994 to that in 2002?
Give a very brief answer. 0.78. What is the ratio of the Employment (as % of total employment) of Services in 1994 to that in 2002?
Provide a succinct answer. 1.03. What is the ratio of the Employment (as % of total employment) in Agriculture in 1995 to that in 1996?
Make the answer very short. 0.86. What is the ratio of the Employment (as % of total employment) in Services in 1995 to that in 1996?
Keep it short and to the point. 1.02. What is the ratio of the Employment (as % of total employment) in Self-employed in 1995 to that in 1996?
Your response must be concise. 1.01. What is the ratio of the Employment (as % of total employment) in Agriculture in 1995 to that in 1997?
Offer a terse response. 1.13. What is the ratio of the Employment (as % of total employment) in Industry in 1995 to that in 1997?
Provide a succinct answer. 0.97. What is the ratio of the Employment (as % of total employment) in Self-employed in 1995 to that in 1997?
Ensure brevity in your answer.  0.94. What is the ratio of the Employment (as % of total employment) in Agriculture in 1995 to that in 1998?
Give a very brief answer. 1.23. What is the ratio of the Employment (as % of total employment) in Industry in 1995 to that in 1998?
Your answer should be very brief. 0.93. What is the ratio of the Employment (as % of total employment) of Services in 1995 to that in 1998?
Your answer should be very brief. 1. What is the ratio of the Employment (as % of total employment) of Self-employed in 1995 to that in 1998?
Offer a terse response. 1.07. What is the ratio of the Employment (as % of total employment) in Agriculture in 1995 to that in 1999?
Give a very brief answer. 1.07. What is the ratio of the Employment (as % of total employment) of Industry in 1995 to that in 1999?
Give a very brief answer. 0.86. What is the ratio of the Employment (as % of total employment) of Services in 1995 to that in 1999?
Your answer should be compact. 1.03. What is the ratio of the Employment (as % of total employment) of Self-employed in 1995 to that in 1999?
Your answer should be compact. 0.97. What is the ratio of the Employment (as % of total employment) of Agriculture in 1995 to that in 2001?
Provide a short and direct response. 1.02. What is the ratio of the Employment (as % of total employment) of Industry in 1995 to that in 2001?
Your answer should be compact. 0.84. What is the ratio of the Employment (as % of total employment) of Services in 1995 to that in 2001?
Make the answer very short. 1.04. What is the ratio of the Employment (as % of total employment) of Self-employed in 1995 to that in 2001?
Make the answer very short. 1.04. What is the ratio of the Employment (as % of total employment) of Agriculture in 1995 to that in 2002?
Keep it short and to the point. 1.16. What is the ratio of the Employment (as % of total employment) in Industry in 1995 to that in 2002?
Ensure brevity in your answer.  0.86. What is the ratio of the Employment (as % of total employment) of Services in 1995 to that in 2002?
Ensure brevity in your answer.  1.03. What is the ratio of the Employment (as % of total employment) of Agriculture in 1996 to that in 1997?
Offer a terse response. 1.32. What is the ratio of the Employment (as % of total employment) in Industry in 1996 to that in 1997?
Make the answer very short. 1.01. What is the ratio of the Employment (as % of total employment) of Services in 1996 to that in 1997?
Offer a very short reply. 0.98. What is the ratio of the Employment (as % of total employment) in Self-employed in 1996 to that in 1997?
Give a very brief answer. 0.93. What is the ratio of the Employment (as % of total employment) of Agriculture in 1996 to that in 1998?
Offer a terse response. 1.43. What is the ratio of the Employment (as % of total employment) of Industry in 1996 to that in 1998?
Give a very brief answer. 0.97. What is the ratio of the Employment (as % of total employment) of Services in 1996 to that in 1998?
Ensure brevity in your answer.  0.99. What is the ratio of the Employment (as % of total employment) in Self-employed in 1996 to that in 1998?
Give a very brief answer. 1.06. What is the ratio of the Employment (as % of total employment) in Industry in 1996 to that in 1999?
Make the answer very short. 0.89. What is the ratio of the Employment (as % of total employment) in Services in 1996 to that in 1999?
Keep it short and to the point. 1.01. What is the ratio of the Employment (as % of total employment) of Agriculture in 1996 to that in 2001?
Your response must be concise. 1.19. What is the ratio of the Employment (as % of total employment) of Industry in 1996 to that in 2001?
Provide a short and direct response. 0.86. What is the ratio of the Employment (as % of total employment) of Services in 1996 to that in 2001?
Ensure brevity in your answer.  1.02. What is the ratio of the Employment (as % of total employment) of Self-employed in 1996 to that in 2001?
Your answer should be compact. 1.03. What is the ratio of the Employment (as % of total employment) of Agriculture in 1996 to that in 2002?
Provide a succinct answer. 1.35. What is the ratio of the Employment (as % of total employment) of Industry in 1996 to that in 2002?
Your answer should be compact. 0.89. What is the ratio of the Employment (as % of total employment) of Services in 1996 to that in 2002?
Give a very brief answer. 1.01. What is the ratio of the Employment (as % of total employment) in Self-employed in 1996 to that in 2002?
Provide a short and direct response. 0.99. What is the ratio of the Employment (as % of total employment) in Agriculture in 1997 to that in 1998?
Your answer should be very brief. 1.09. What is the ratio of the Employment (as % of total employment) of Industry in 1997 to that in 1998?
Your answer should be very brief. 0.96. What is the ratio of the Employment (as % of total employment) in Services in 1997 to that in 1998?
Provide a succinct answer. 1. What is the ratio of the Employment (as % of total employment) in Self-employed in 1997 to that in 1998?
Your answer should be very brief. 1.14. What is the ratio of the Employment (as % of total employment) of Industry in 1997 to that in 1999?
Provide a short and direct response. 0.88. What is the ratio of the Employment (as % of total employment) of Services in 1997 to that in 1999?
Offer a terse response. 1.03. What is the ratio of the Employment (as % of total employment) in Self-employed in 1997 to that in 1999?
Provide a short and direct response. 1.03. What is the ratio of the Employment (as % of total employment) of Agriculture in 1997 to that in 2001?
Your answer should be compact. 0.9. What is the ratio of the Employment (as % of total employment) of Industry in 1997 to that in 2001?
Make the answer very short. 0.86. What is the ratio of the Employment (as % of total employment) in Services in 1997 to that in 2001?
Give a very brief answer. 1.04. What is the ratio of the Employment (as % of total employment) in Self-employed in 1997 to that in 2001?
Your answer should be very brief. 1.11. What is the ratio of the Employment (as % of total employment) in Industry in 1997 to that in 2002?
Provide a succinct answer. 0.88. What is the ratio of the Employment (as % of total employment) of Services in 1997 to that in 2002?
Provide a succinct answer. 1.03. What is the ratio of the Employment (as % of total employment) in Self-employed in 1997 to that in 2002?
Your response must be concise. 1.06. What is the ratio of the Employment (as % of total employment) in Industry in 1998 to that in 1999?
Keep it short and to the point. 0.92. What is the ratio of the Employment (as % of total employment) in Services in 1998 to that in 1999?
Offer a very short reply. 1.03. What is the ratio of the Employment (as % of total employment) of Self-employed in 1998 to that in 1999?
Your response must be concise. 0.9. What is the ratio of the Employment (as % of total employment) in Industry in 1998 to that in 2001?
Provide a succinct answer. 0.89. What is the ratio of the Employment (as % of total employment) of Services in 1998 to that in 2001?
Your answer should be very brief. 1.03. What is the ratio of the Employment (as % of total employment) of Self-employed in 1998 to that in 2001?
Make the answer very short. 0.97. What is the ratio of the Employment (as % of total employment) of Agriculture in 1998 to that in 2002?
Provide a short and direct response. 0.95. What is the ratio of the Employment (as % of total employment) of Industry in 1998 to that in 2002?
Provide a succinct answer. 0.92. What is the ratio of the Employment (as % of total employment) of Services in 1998 to that in 2002?
Your answer should be very brief. 1.02. What is the ratio of the Employment (as % of total employment) in Self-employed in 1998 to that in 2002?
Provide a short and direct response. 0.93. What is the ratio of the Employment (as % of total employment) of Industry in 1999 to that in 2001?
Make the answer very short. 0.98. What is the ratio of the Employment (as % of total employment) in Services in 1999 to that in 2001?
Give a very brief answer. 1.01. What is the ratio of the Employment (as % of total employment) in Agriculture in 1999 to that in 2002?
Make the answer very short. 1.08. What is the ratio of the Employment (as % of total employment) in Self-employed in 1999 to that in 2002?
Your answer should be very brief. 1.03. What is the ratio of the Employment (as % of total employment) of Agriculture in 2001 to that in 2002?
Make the answer very short. 1.14. What is the ratio of the Employment (as % of total employment) in Industry in 2001 to that in 2002?
Keep it short and to the point. 1.02. What is the ratio of the Employment (as % of total employment) of Services in 2001 to that in 2002?
Your answer should be compact. 0.99. What is the ratio of the Employment (as % of total employment) in Self-employed in 2001 to that in 2002?
Offer a terse response. 0.95. What is the difference between the highest and the second highest Employment (as % of total employment) in Agriculture?
Give a very brief answer. 0.4. What is the difference between the highest and the second highest Employment (as % of total employment) of Industry?
Ensure brevity in your answer.  0.4. What is the difference between the highest and the second highest Employment (as % of total employment) of Services?
Offer a terse response. 0.1. What is the difference between the highest and the second highest Employment (as % of total employment) in Self-employed?
Offer a terse response. 0.6. What is the difference between the highest and the lowest Employment (as % of total employment) of Agriculture?
Your answer should be very brief. 1.9. What is the difference between the highest and the lowest Employment (as % of total employment) in Industry?
Give a very brief answer. 4.1. What is the difference between the highest and the lowest Employment (as % of total employment) of Self-employed?
Offer a terse response. 2.6. 